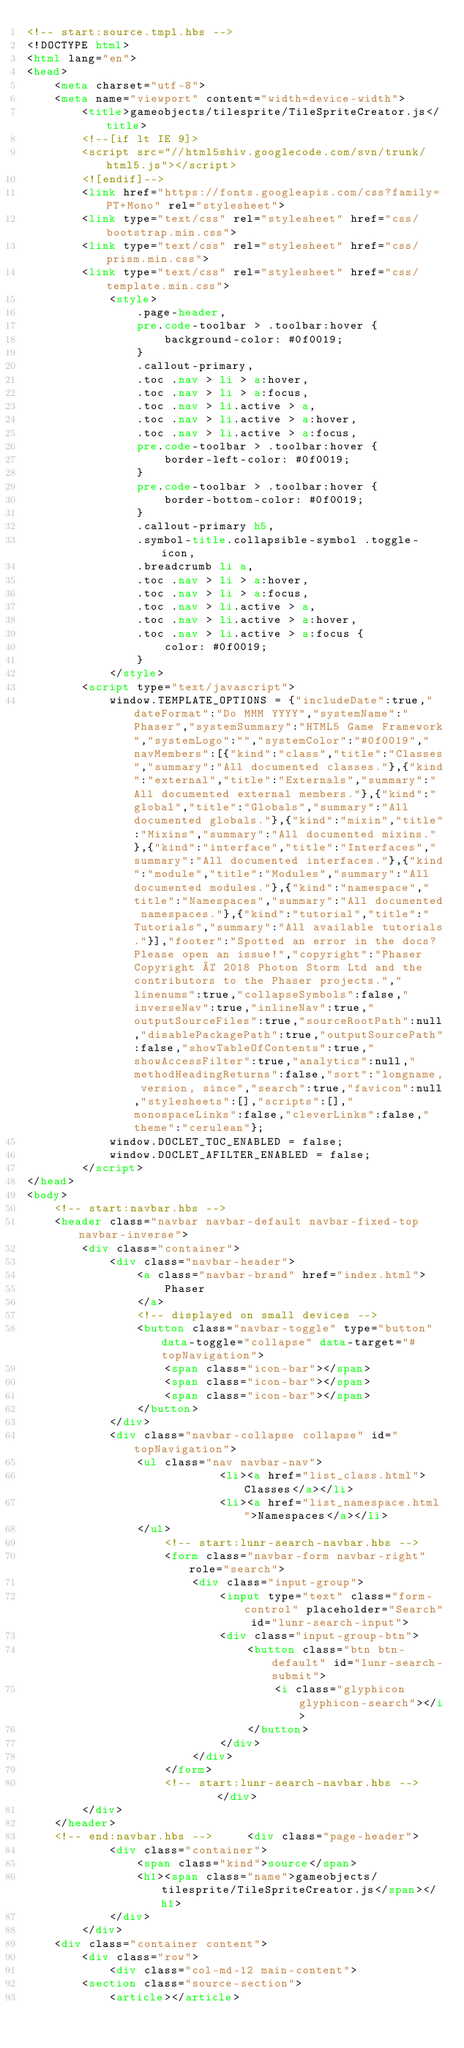Convert code to text. <code><loc_0><loc_0><loc_500><loc_500><_HTML_><!-- start:source.tmpl.hbs -->
<!DOCTYPE html>
<html lang="en">
<head>
	<meta charset="utf-8">
	<meta name="viewport" content="width=device-width">
		<title>gameobjects/tilesprite/TileSpriteCreator.js</title>
		<!--[if lt IE 9]>
		<script src="//html5shiv.googlecode.com/svn/trunk/html5.js"></script>
		<![endif]-->
		<link href="https://fonts.googleapis.com/css?family=PT+Mono" rel="stylesheet">
		<link type="text/css" rel="stylesheet" href="css/bootstrap.min.css">
		<link type="text/css" rel="stylesheet" href="css/prism.min.css">
		<link type="text/css" rel="stylesheet" href="css/template.min.css">
			<style>
				.page-header,
				pre.code-toolbar > .toolbar:hover {
					background-color: #0f0019;
				}
				.callout-primary,
				.toc .nav > li > a:hover,
				.toc .nav > li > a:focus,
				.toc .nav > li.active > a,
				.toc .nav > li.active > a:hover,
				.toc .nav > li.active > a:focus,
				pre.code-toolbar > .toolbar:hover {
					border-left-color: #0f0019;
				}
				pre.code-toolbar > .toolbar:hover {
					border-bottom-color: #0f0019;
				}
				.callout-primary h5,
				.symbol-title.collapsible-symbol .toggle-icon,
				.breadcrumb li a,
				.toc .nav > li > a:hover,
				.toc .nav > li > a:focus,
				.toc .nav > li.active > a,
				.toc .nav > li.active > a:hover,
				.toc .nav > li.active > a:focus {
					color: #0f0019;
				}
			</style>
		<script type="text/javascript">
			window.TEMPLATE_OPTIONS = {"includeDate":true,"dateFormat":"Do MMM YYYY","systemName":"Phaser","systemSummary":"HTML5 Game Framework","systemLogo":"","systemColor":"#0f0019","navMembers":[{"kind":"class","title":"Classes","summary":"All documented classes."},{"kind":"external","title":"Externals","summary":"All documented external members."},{"kind":"global","title":"Globals","summary":"All documented globals."},{"kind":"mixin","title":"Mixins","summary":"All documented mixins."},{"kind":"interface","title":"Interfaces","summary":"All documented interfaces."},{"kind":"module","title":"Modules","summary":"All documented modules."},{"kind":"namespace","title":"Namespaces","summary":"All documented namespaces."},{"kind":"tutorial","title":"Tutorials","summary":"All available tutorials."}],"footer":"Spotted an error in the docs? Please open an issue!","copyright":"Phaser Copyright © 2018 Photon Storm Ltd and the contributors to the Phaser projects.","linenums":true,"collapseSymbols":false,"inverseNav":true,"inlineNav":true,"outputSourceFiles":true,"sourceRootPath":null,"disablePackagePath":true,"outputSourcePath":false,"showTableOfContents":true,"showAccessFilter":true,"analytics":null,"methodHeadingReturns":false,"sort":"longname, version, since","search":true,"favicon":null,"stylesheets":[],"scripts":[],"monospaceLinks":false,"cleverLinks":false,"theme":"cerulean"};
			window.DOCLET_TOC_ENABLED = false;
			window.DOCLET_AFILTER_ENABLED = false;
		</script>
</head>
<body>
	<!-- start:navbar.hbs -->
	<header class="navbar navbar-default navbar-fixed-top navbar-inverse">
		<div class="container">
			<div class="navbar-header">
				<a class="navbar-brand" href="index.html">
					Phaser
				</a>
				<!-- displayed on small devices -->
				<button class="navbar-toggle" type="button" data-toggle="collapse" data-target="#topNavigation">
					<span class="icon-bar"></span>
					<span class="icon-bar"></span>
					<span class="icon-bar"></span>
				</button>
			</div>
			<div class="navbar-collapse collapse" id="topNavigation">
				<ul class="nav navbar-nav">
							<li><a href="list_class.html">Classes</a></li>
							<li><a href="list_namespace.html">Namespaces</a></li>
				</ul>
					<!-- start:lunr-search-navbar.hbs -->
					<form class="navbar-form navbar-right" role="search">
						<div class="input-group">
							<input type="text" class="form-control" placeholder="Search" id="lunr-search-input">
							<div class="input-group-btn">
								<button class="btn btn-default" id="lunr-search-submit">
									<i class="glyphicon glyphicon-search"></i>
								</button>
							</div>
						</div>
					</form>
					<!-- start:lunr-search-navbar.hbs -->		</div>
		</div>
	</header>
	<!-- end:navbar.hbs -->		<div class="page-header">
			<div class="container">
				<span class="kind">source</span>
				<h1><span class="name">gameobjects/tilesprite/TileSpriteCreator.js</span></h1>
			</div>
		</div>
	<div class="container content">
		<div class="row">
			<div class="col-md-12 main-content">
		<section class="source-section">
			<article></article></code> 